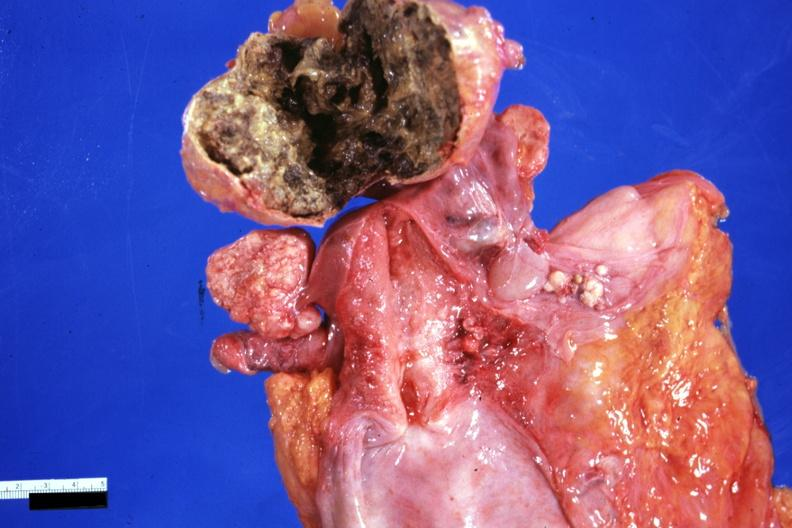s female reproductive present?
Answer the question using a single word or phrase. Yes 